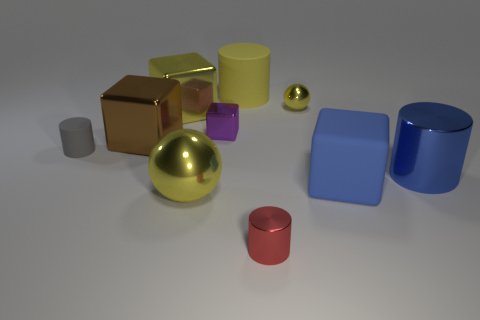There is a large shiny ball; is it the same color as the tiny metallic thing that is behind the small purple metallic thing?
Provide a succinct answer. Yes. How many other shiny balls are the same color as the tiny sphere?
Your answer should be compact. 1. How big is the brown cube behind the sphere that is to the left of the yellow cylinder?
Your answer should be compact. Large. Are there more large rubber cylinders left of the purple cube than purple metallic blocks that are behind the tiny yellow shiny sphere?
Give a very brief answer. No. What is the yellow thing that is to the right of the yellow matte cylinder made of?
Your response must be concise. Metal. Do the large blue shiny thing and the tiny gray rubber object have the same shape?
Provide a succinct answer. Yes. Is there anything else that is the same color as the tiny rubber cylinder?
Offer a very short reply. No. There is a big matte object that is the same shape as the purple shiny thing; what color is it?
Ensure brevity in your answer.  Blue. Is the number of large cubes that are on the right side of the small yellow metal sphere greater than the number of big yellow matte blocks?
Your answer should be compact. Yes. There is a shiny object that is in front of the big metal sphere; what color is it?
Your answer should be compact. Red. 